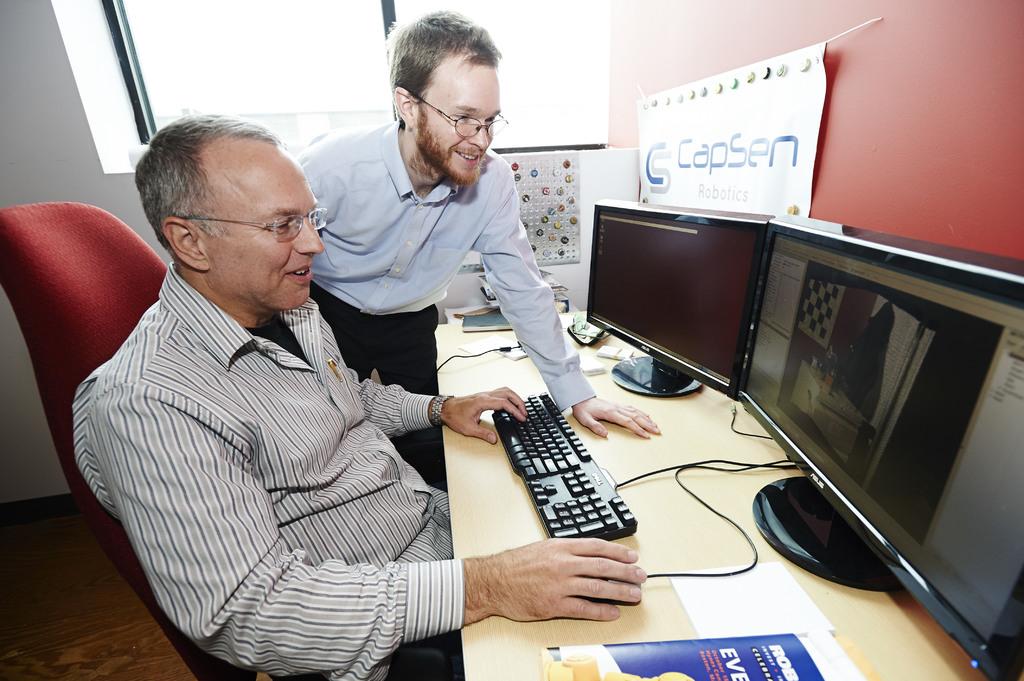What company logo is on the board on the red wall?
Your answer should be very brief. Capsen. 